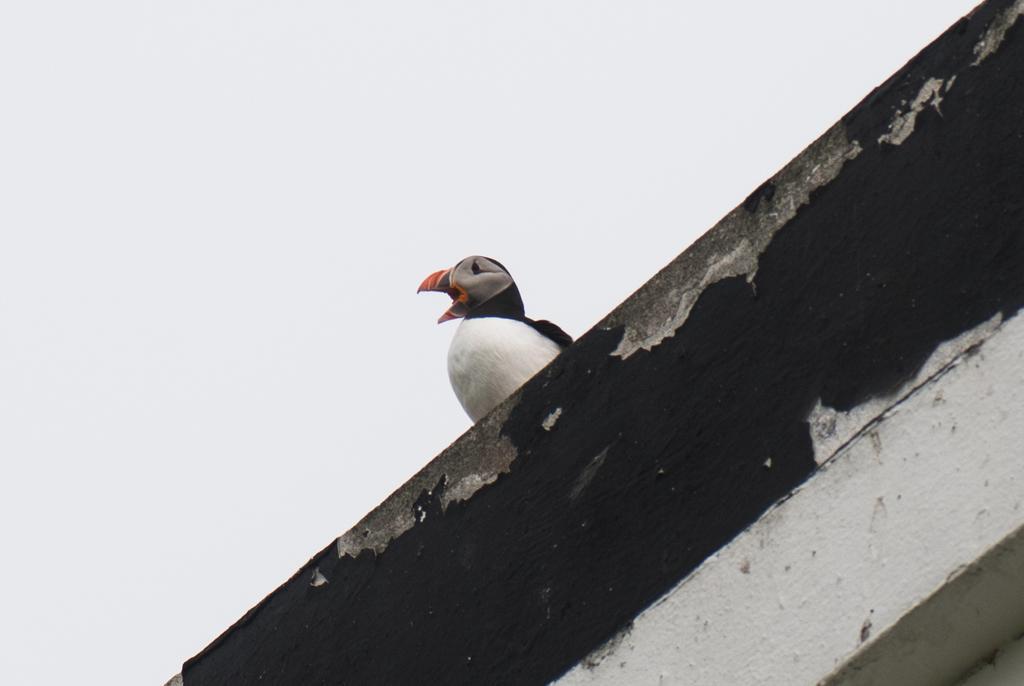Could you give a brief overview of what you see in this image? In this image we can see a bird on the wall. At the top of the image, we can see the sky. 